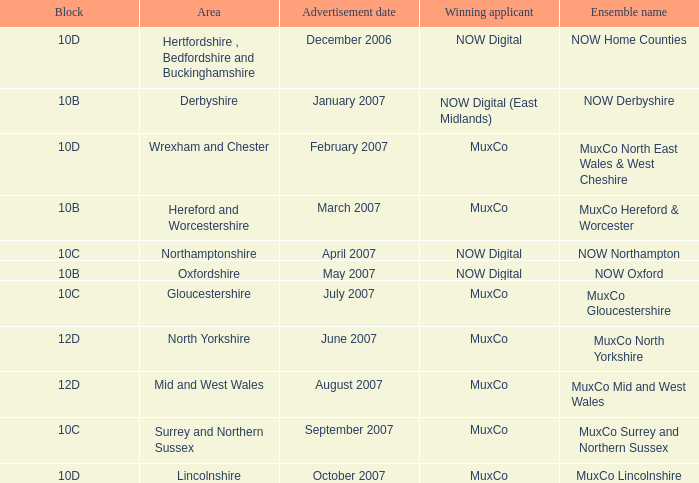Who is the Winning Applicant of Block 10B in Derbyshire Area? NOW Digital (East Midlands). 